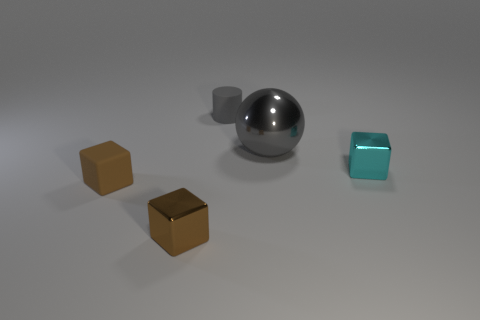Is the cylinder the same color as the big thing?
Keep it short and to the point. Yes. What is the small object left of the small brown metallic cube made of?
Provide a short and direct response. Rubber. Is the material of the gray cylinder the same as the gray object to the right of the small gray rubber object?
Offer a very short reply. No. Is there anything else that has the same shape as the big gray shiny thing?
Your answer should be compact. No. What material is the thing that is the same color as the big metal sphere?
Your response must be concise. Rubber. Does the gray rubber object have the same size as the shiny thing that is behind the cyan metal thing?
Offer a terse response. No. What number of other objects are there of the same size as the sphere?
Ensure brevity in your answer.  0. How many other things are the same color as the big shiny thing?
Your answer should be very brief. 1. Is there any other thing that is the same size as the gray metal sphere?
Give a very brief answer. No. What number of other things are the same shape as the big thing?
Your response must be concise. 0. 